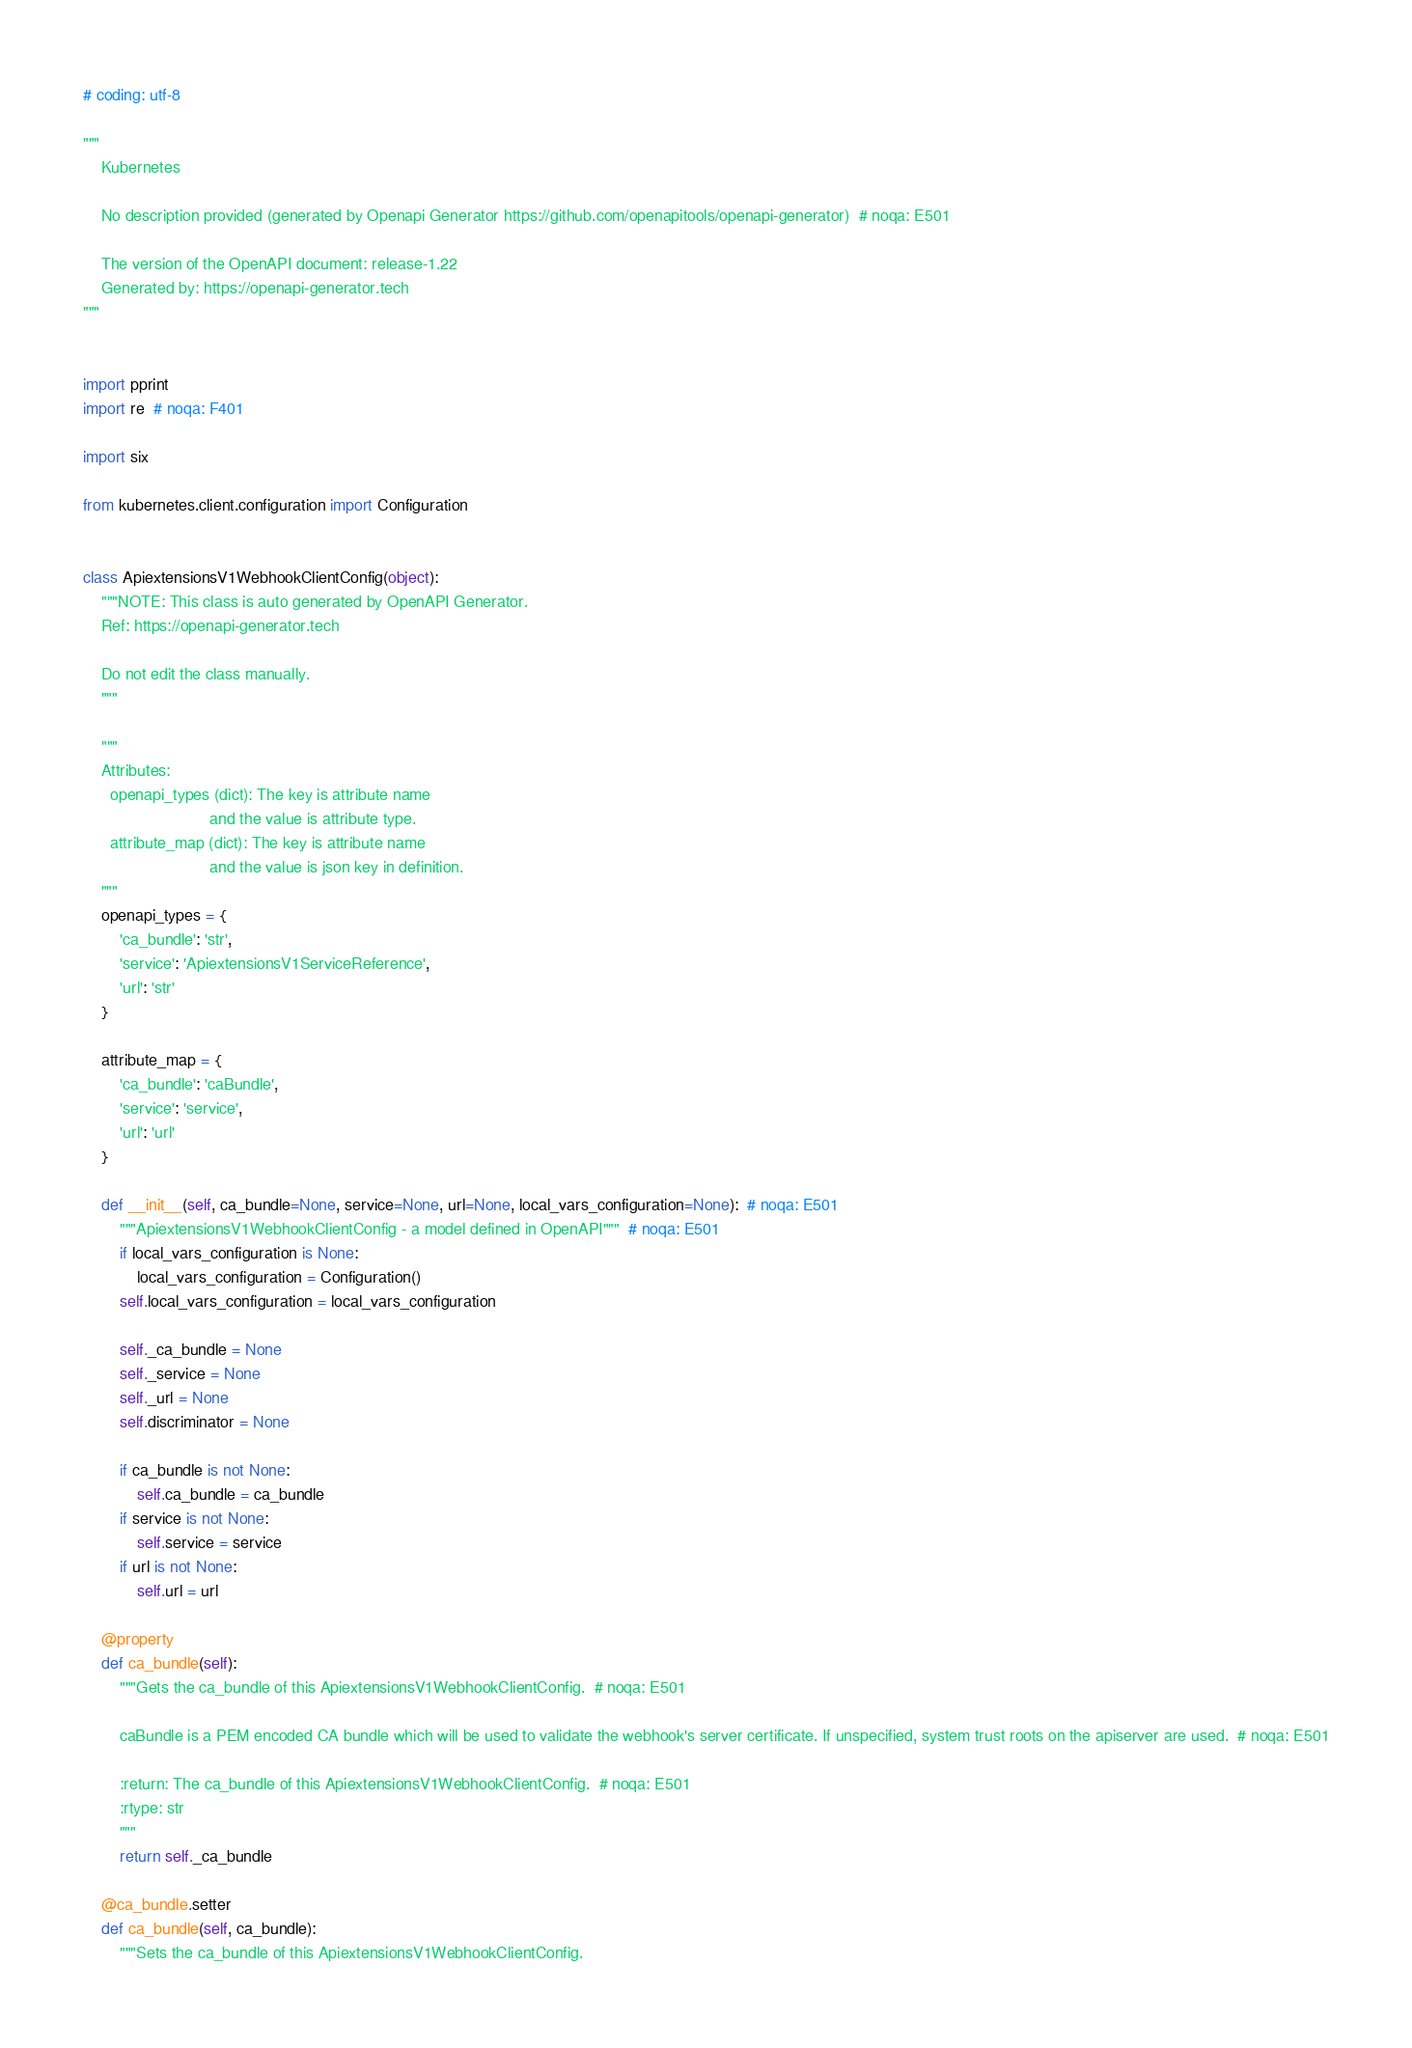Convert code to text. <code><loc_0><loc_0><loc_500><loc_500><_Python_># coding: utf-8

"""
    Kubernetes

    No description provided (generated by Openapi Generator https://github.com/openapitools/openapi-generator)  # noqa: E501

    The version of the OpenAPI document: release-1.22
    Generated by: https://openapi-generator.tech
"""


import pprint
import re  # noqa: F401

import six

from kubernetes.client.configuration import Configuration


class ApiextensionsV1WebhookClientConfig(object):
    """NOTE: This class is auto generated by OpenAPI Generator.
    Ref: https://openapi-generator.tech

    Do not edit the class manually.
    """

    """
    Attributes:
      openapi_types (dict): The key is attribute name
                            and the value is attribute type.
      attribute_map (dict): The key is attribute name
                            and the value is json key in definition.
    """
    openapi_types = {
        'ca_bundle': 'str',
        'service': 'ApiextensionsV1ServiceReference',
        'url': 'str'
    }

    attribute_map = {
        'ca_bundle': 'caBundle',
        'service': 'service',
        'url': 'url'
    }

    def __init__(self, ca_bundle=None, service=None, url=None, local_vars_configuration=None):  # noqa: E501
        """ApiextensionsV1WebhookClientConfig - a model defined in OpenAPI"""  # noqa: E501
        if local_vars_configuration is None:
            local_vars_configuration = Configuration()
        self.local_vars_configuration = local_vars_configuration

        self._ca_bundle = None
        self._service = None
        self._url = None
        self.discriminator = None

        if ca_bundle is not None:
            self.ca_bundle = ca_bundle
        if service is not None:
            self.service = service
        if url is not None:
            self.url = url

    @property
    def ca_bundle(self):
        """Gets the ca_bundle of this ApiextensionsV1WebhookClientConfig.  # noqa: E501

        caBundle is a PEM encoded CA bundle which will be used to validate the webhook's server certificate. If unspecified, system trust roots on the apiserver are used.  # noqa: E501

        :return: The ca_bundle of this ApiextensionsV1WebhookClientConfig.  # noqa: E501
        :rtype: str
        """
        return self._ca_bundle

    @ca_bundle.setter
    def ca_bundle(self, ca_bundle):
        """Sets the ca_bundle of this ApiextensionsV1WebhookClientConfig.
</code> 